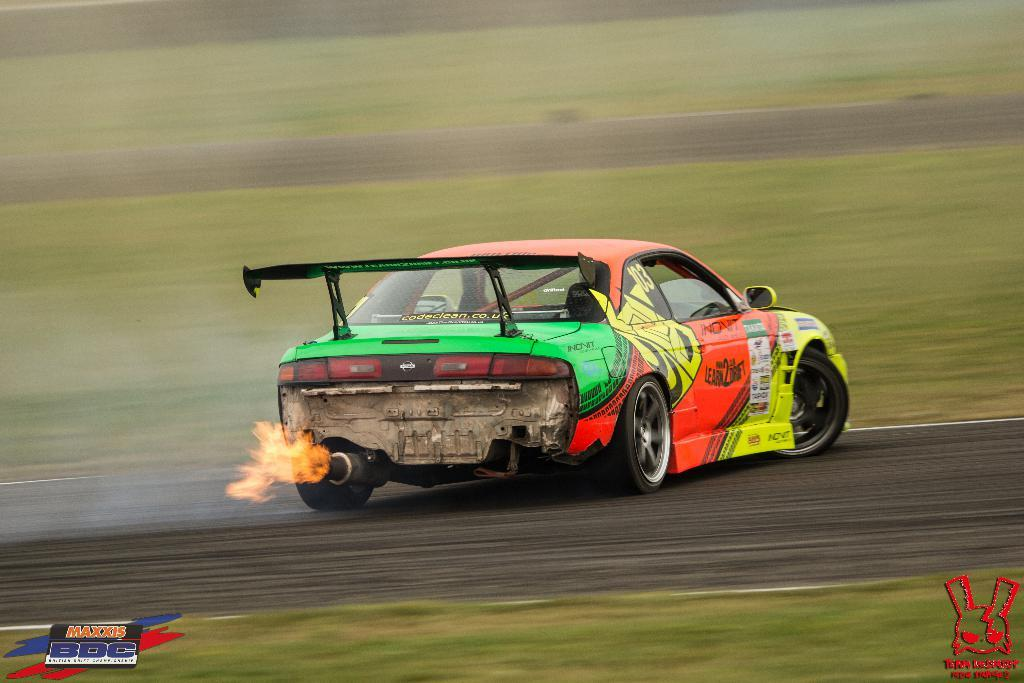What type of vehicle is in the image? There is a colorful vehicle in the image. Where is the vehicle located? The vehicle is on the road. What can be seen on both sides of the road? There is grass on both sides of the road. What type of brick is used to build the cause in the image? There is no cause or brick present in the image; it features a colorful vehicle on the road with grass on both sides. 